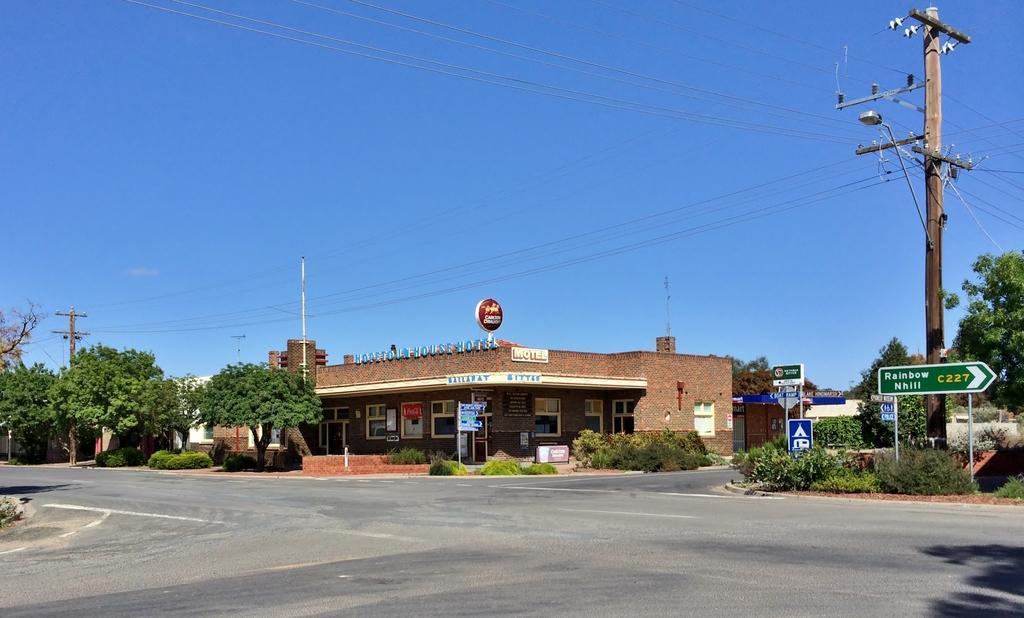Could you give a brief overview of what you see in this image? Here we can see road, boards on poles, plants, trees, poles and wires. Background we can see house and sky. 